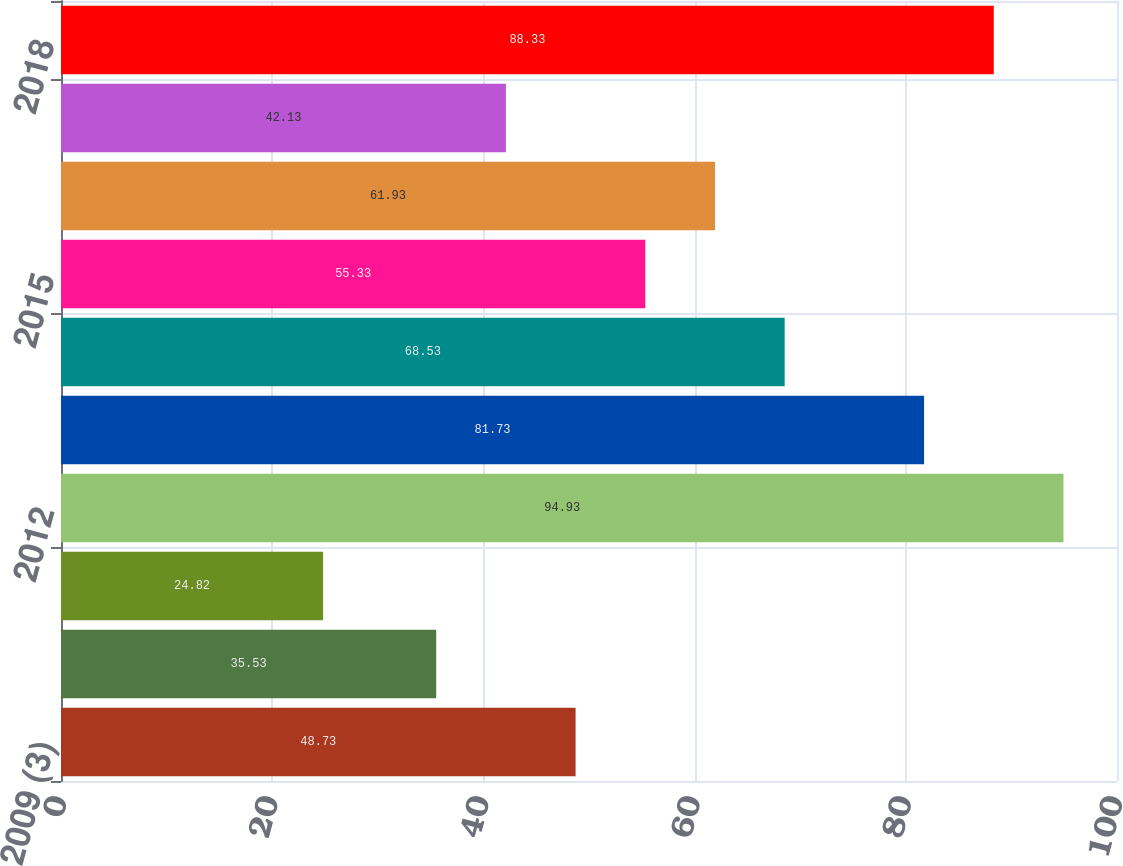Convert chart to OTSL. <chart><loc_0><loc_0><loc_500><loc_500><bar_chart><fcel>2009 (3)<fcel>2010<fcel>2011<fcel>2012<fcel>2013<fcel>2014<fcel>2015<fcel>2016<fcel>2017<fcel>2018<nl><fcel>48.73<fcel>35.53<fcel>24.82<fcel>94.93<fcel>81.73<fcel>68.53<fcel>55.33<fcel>61.93<fcel>42.13<fcel>88.33<nl></chart> 